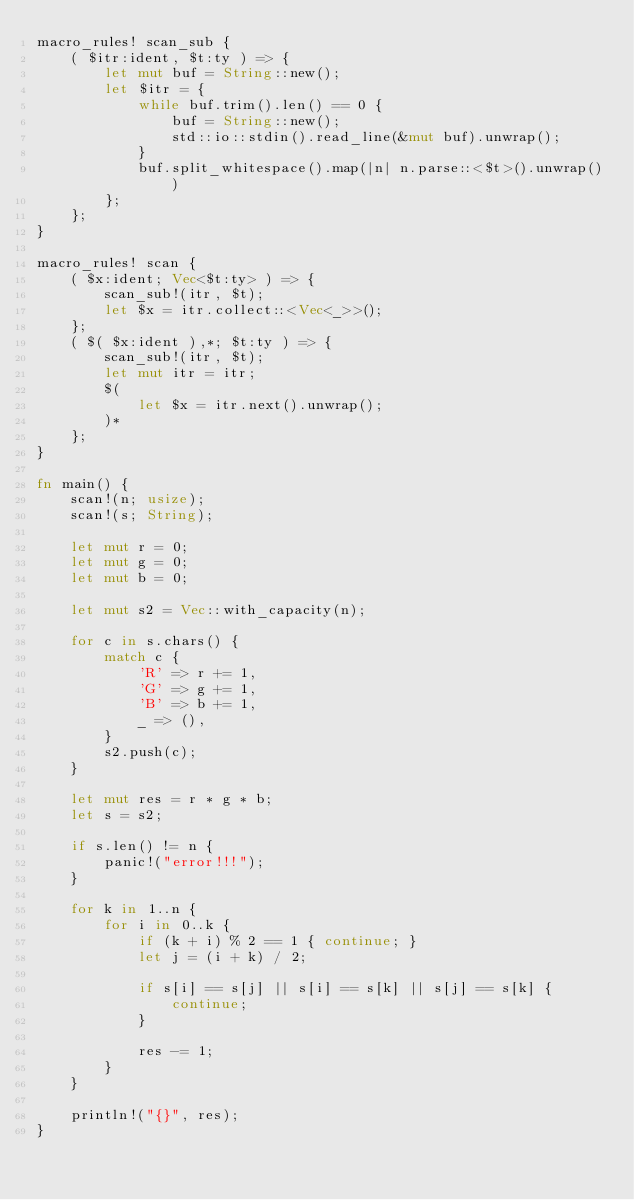<code> <loc_0><loc_0><loc_500><loc_500><_Rust_>macro_rules! scan_sub {
    ( $itr:ident, $t:ty ) => {
        let mut buf = String::new();
        let $itr = {
            while buf.trim().len() == 0 {
                buf = String::new();
                std::io::stdin().read_line(&mut buf).unwrap();
            }
            buf.split_whitespace().map(|n| n.parse::<$t>().unwrap())
        };
    };
}

macro_rules! scan {
    ( $x:ident; Vec<$t:ty> ) => {
        scan_sub!(itr, $t);
        let $x = itr.collect::<Vec<_>>();
    };
    ( $( $x:ident ),*; $t:ty ) => {
        scan_sub!(itr, $t);
        let mut itr = itr;
        $(
            let $x = itr.next().unwrap();
        )*
    };
}

fn main() {
    scan!(n; usize);
    scan!(s; String);

    let mut r = 0;
    let mut g = 0;
    let mut b = 0;

    let mut s2 = Vec::with_capacity(n);

    for c in s.chars() {
        match c {
            'R' => r += 1,
            'G' => g += 1,
            'B' => b += 1,
            _ => (),
        }
        s2.push(c);
    }

    let mut res = r * g * b;
    let s = s2;

    if s.len() != n {
        panic!("error!!!");
    }

    for k in 1..n {
        for i in 0..k {
            if (k + i) % 2 == 1 { continue; }
            let j = (i + k) / 2;

            if s[i] == s[j] || s[i] == s[k] || s[j] == s[k] {
                continue;
            }

            res -= 1;
        }
    }

    println!("{}", res);
}
</code> 